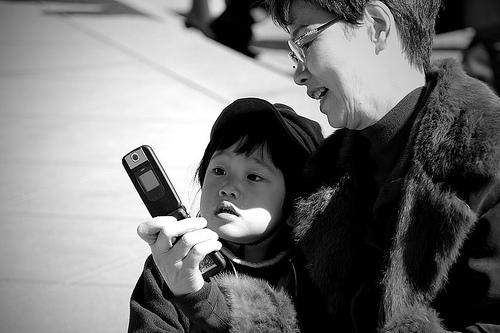What is she doing with the child? showing phone 